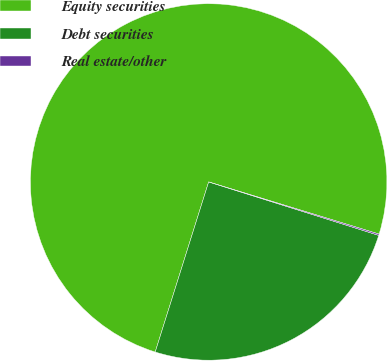Convert chart. <chart><loc_0><loc_0><loc_500><loc_500><pie_chart><fcel>Equity securities<fcel>Debt securities<fcel>Real estate/other<nl><fcel>74.88%<fcel>25.0%<fcel>0.12%<nl></chart> 